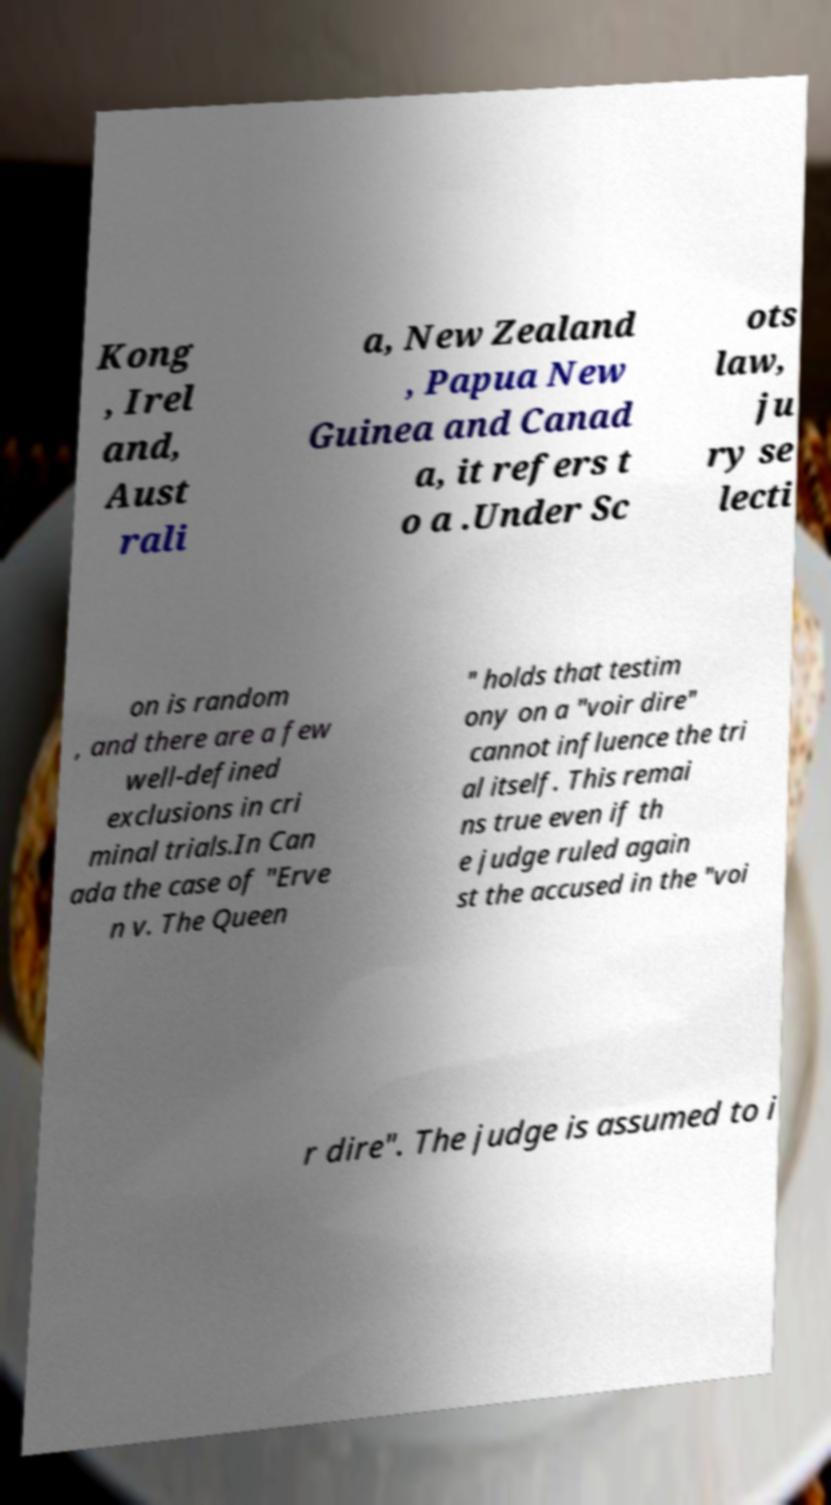For documentation purposes, I need the text within this image transcribed. Could you provide that? Kong , Irel and, Aust rali a, New Zealand , Papua New Guinea and Canad a, it refers t o a .Under Sc ots law, ju ry se lecti on is random , and there are a few well-defined exclusions in cri minal trials.In Can ada the case of "Erve n v. The Queen " holds that testim ony on a "voir dire" cannot influence the tri al itself. This remai ns true even if th e judge ruled again st the accused in the "voi r dire". The judge is assumed to i 